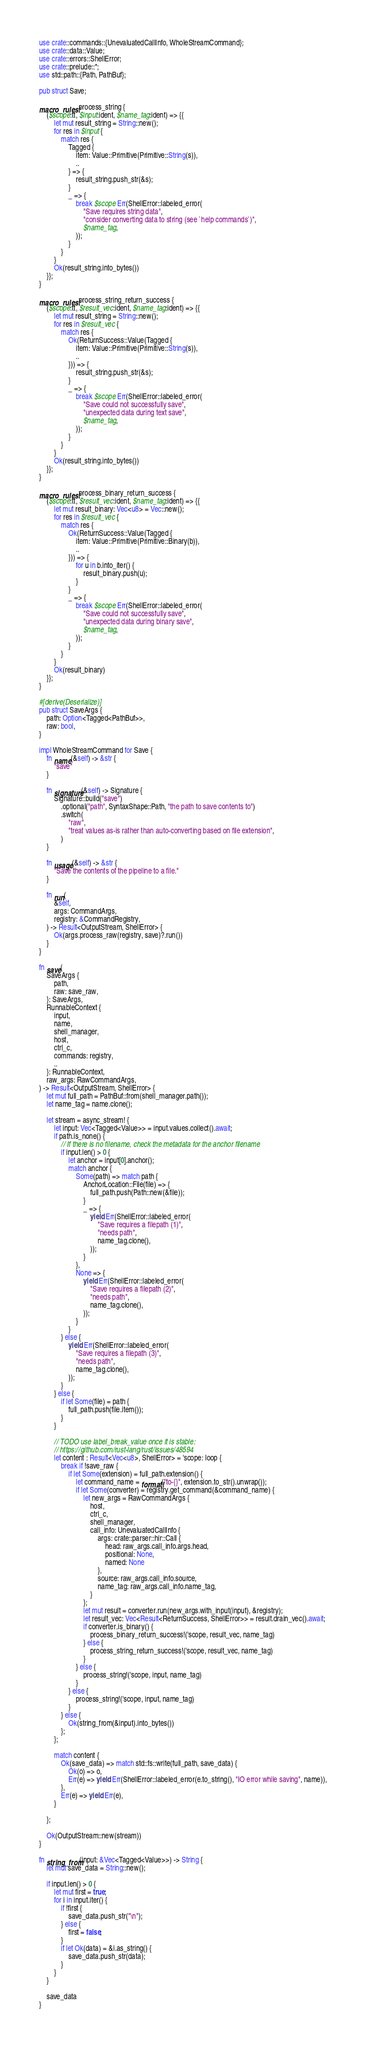Convert code to text. <code><loc_0><loc_0><loc_500><loc_500><_Rust_>use crate::commands::{UnevaluatedCallInfo, WholeStreamCommand};
use crate::data::Value;
use crate::errors::ShellError;
use crate::prelude::*;
use std::path::{Path, PathBuf};

pub struct Save;

macro_rules! process_string {
    ($scope:tt, $input:ident, $name_tag:ident) => {{
        let mut result_string = String::new();
        for res in $input {
            match res {
                Tagged {
                    item: Value::Primitive(Primitive::String(s)),
                    ..
                } => {
                    result_string.push_str(&s);
                }
                _ => {
                    break $scope Err(ShellError::labeled_error(
                        "Save requires string data",
                        "consider converting data to string (see `help commands`)",
                        $name_tag,
                    ));
                }
            }
        }
        Ok(result_string.into_bytes())
    }};
}

macro_rules! process_string_return_success {
    ($scope:tt, $result_vec:ident, $name_tag:ident) => {{
        let mut result_string = String::new();
        for res in $result_vec {
            match res {
                Ok(ReturnSuccess::Value(Tagged {
                    item: Value::Primitive(Primitive::String(s)),
                    ..
                })) => {
                    result_string.push_str(&s);
                }
                _ => {
                    break $scope Err(ShellError::labeled_error(
                        "Save could not successfully save",
                        "unexpected data during text save",
                        $name_tag,
                    ));
                }
            }
        }
        Ok(result_string.into_bytes())
    }};
}

macro_rules! process_binary_return_success {
    ($scope:tt, $result_vec:ident, $name_tag:ident) => {{
        let mut result_binary: Vec<u8> = Vec::new();
        for res in $result_vec {
            match res {
                Ok(ReturnSuccess::Value(Tagged {
                    item: Value::Primitive(Primitive::Binary(b)),
                    ..
                })) => {
                    for u in b.into_iter() {
                        result_binary.push(u);
                    }
                }
                _ => {
                    break $scope Err(ShellError::labeled_error(
                        "Save could not successfully save",
                        "unexpected data during binary save",
                        $name_tag,
                    ));
                }
            }
        }
        Ok(result_binary)
    }};
}

#[derive(Deserialize)]
pub struct SaveArgs {
    path: Option<Tagged<PathBuf>>,
    raw: bool,
}

impl WholeStreamCommand for Save {
    fn name(&self) -> &str {
        "save"
    }

    fn signature(&self) -> Signature {
        Signature::build("save")
            .optional("path", SyntaxShape::Path, "the path to save contents to")
            .switch(
                "raw",
                "treat values as-is rather than auto-converting based on file extension",
            )
    }

    fn usage(&self) -> &str {
        "Save the contents of the pipeline to a file."
    }

    fn run(
        &self,
        args: CommandArgs,
        registry: &CommandRegistry,
    ) -> Result<OutputStream, ShellError> {
        Ok(args.process_raw(registry, save)?.run())
    }
}

fn save(
    SaveArgs {
        path,
        raw: save_raw,
    }: SaveArgs,
    RunnableContext {
        input,
        name,
        shell_manager,
        host,
        ctrl_c,
        commands: registry,
        ..
    }: RunnableContext,
    raw_args: RawCommandArgs,
) -> Result<OutputStream, ShellError> {
    let mut full_path = PathBuf::from(shell_manager.path());
    let name_tag = name.clone();

    let stream = async_stream! {
        let input: Vec<Tagged<Value>> = input.values.collect().await;
        if path.is_none() {
            // If there is no filename, check the metadata for the anchor filename
            if input.len() > 0 {
                let anchor = input[0].anchor();
                match anchor {
                    Some(path) => match path {
                        AnchorLocation::File(file) => {
                            full_path.push(Path::new(&file));
                        }
                        _ => {
                            yield Err(ShellError::labeled_error(
                                "Save requires a filepath (1)",
                                "needs path",
                                name_tag.clone(),
                            ));
                        }
                    },
                    None => {
                        yield Err(ShellError::labeled_error(
                            "Save requires a filepath (2)",
                            "needs path",
                            name_tag.clone(),
                        ));
                    }
                }
            } else {
                yield Err(ShellError::labeled_error(
                    "Save requires a filepath (3)",
                    "needs path",
                    name_tag.clone(),
                ));
            }
        } else {
            if let Some(file) = path {
                full_path.push(file.item());
            }
        }

        // TODO use label_break_value once it is stable:
        // https://github.com/rust-lang/rust/issues/48594
        let content : Result<Vec<u8>, ShellError> = 'scope: loop {
            break if !save_raw {
                if let Some(extension) = full_path.extension() {
                    let command_name = format!("to-{}", extension.to_str().unwrap());
                    if let Some(converter) = registry.get_command(&command_name) {
                        let new_args = RawCommandArgs {
                            host,
                            ctrl_c,
                            shell_manager,
                            call_info: UnevaluatedCallInfo {
                                args: crate::parser::hir::Call {
                                    head: raw_args.call_info.args.head,
                                    positional: None,
                                    named: None
                                },
                                source: raw_args.call_info.source,
                                name_tag: raw_args.call_info.name_tag,
                            }
                        };
                        let mut result = converter.run(new_args.with_input(input), &registry);
                        let result_vec: Vec<Result<ReturnSuccess, ShellError>> = result.drain_vec().await;
                        if converter.is_binary() {
                            process_binary_return_success!('scope, result_vec, name_tag)
                        } else {
                            process_string_return_success!('scope, result_vec, name_tag)
                        }
                    } else {
                        process_string!('scope, input, name_tag)
                    }
                } else {
                    process_string!('scope, input, name_tag)
                }
            } else {
                Ok(string_from(&input).into_bytes())
            };
        };

        match content {
            Ok(save_data) => match std::fs::write(full_path, save_data) {
                Ok(o) => o,
                Err(e) => yield Err(ShellError::labeled_error(e.to_string(), "IO error while saving", name)),
            },
            Err(e) => yield Err(e),
        }

    };

    Ok(OutputStream::new(stream))
}

fn string_from(input: &Vec<Tagged<Value>>) -> String {
    let mut save_data = String::new();

    if input.len() > 0 {
        let mut first = true;
        for i in input.iter() {
            if !first {
                save_data.push_str("\n");
            } else {
                first = false;
            }
            if let Ok(data) = &i.as_string() {
                save_data.push_str(data);
            }
        }
    }

    save_data
}
</code> 